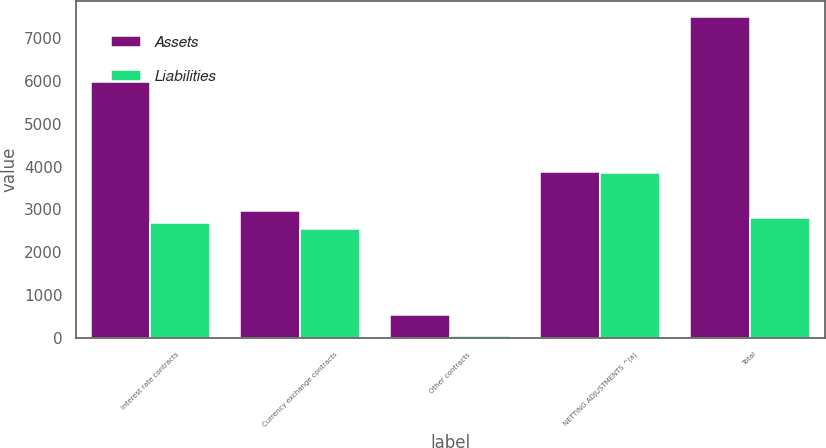<chart> <loc_0><loc_0><loc_500><loc_500><stacked_bar_chart><ecel><fcel>Interest rate contracts<fcel>Currency exchange contracts<fcel>Other contracts<fcel>NETTING ADJUSTMENTS ^(a)<fcel>Total<nl><fcel>Assets<fcel>5959<fcel>2965<fcel>531<fcel>3867<fcel>7489<nl><fcel>Liabilities<fcel>2675<fcel>2533<fcel>50<fcel>3857<fcel>2799<nl></chart> 